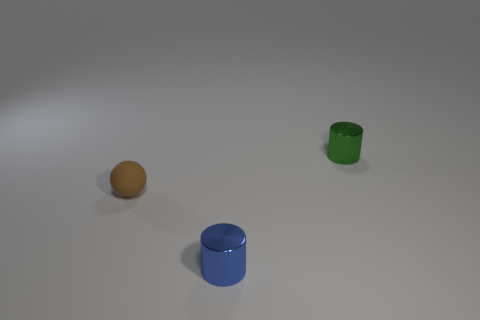Subtract all blue cylinders. How many cylinders are left? 1 Add 3 small cyan things. How many objects exist? 6 Subtract 1 balls. How many balls are left? 0 Subtract 1 blue cylinders. How many objects are left? 2 Subtract all cylinders. How many objects are left? 1 Subtract all blue spheres. Subtract all blue cubes. How many spheres are left? 1 Subtract all red spheres. How many red cylinders are left? 0 Subtract all large matte objects. Subtract all tiny brown matte balls. How many objects are left? 2 Add 3 tiny blue shiny objects. How many tiny blue shiny objects are left? 4 Add 2 small gray cubes. How many small gray cubes exist? 2 